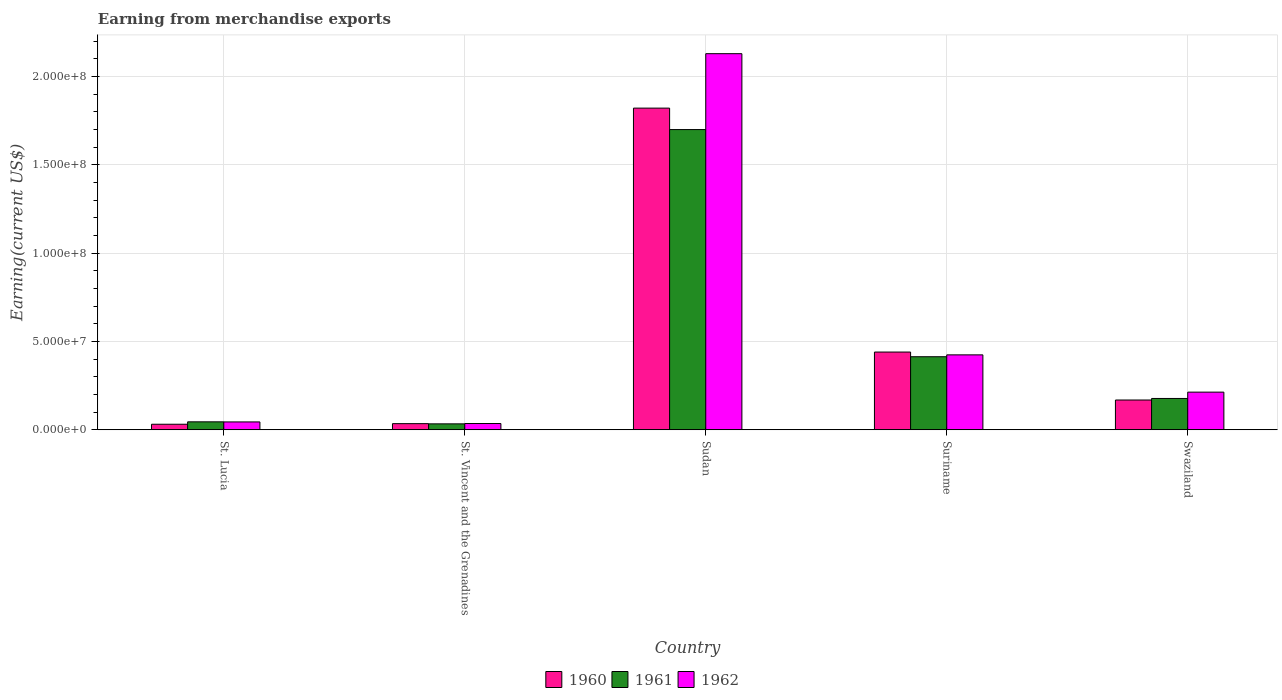What is the label of the 4th group of bars from the left?
Offer a terse response. Suriname. What is the amount earned from merchandise exports in 1960 in St. Vincent and the Grenadines?
Provide a short and direct response. 3.48e+06. Across all countries, what is the maximum amount earned from merchandise exports in 1961?
Your answer should be very brief. 1.70e+08. Across all countries, what is the minimum amount earned from merchandise exports in 1962?
Offer a very short reply. 3.56e+06. In which country was the amount earned from merchandise exports in 1962 maximum?
Your response must be concise. Sudan. In which country was the amount earned from merchandise exports in 1960 minimum?
Keep it short and to the point. St. Lucia. What is the total amount earned from merchandise exports in 1960 in the graph?
Keep it short and to the point. 2.50e+08. What is the difference between the amount earned from merchandise exports in 1962 in St. Lucia and that in St. Vincent and the Grenadines?
Your answer should be very brief. 9.00e+05. What is the difference between the amount earned from merchandise exports in 1962 in St. Lucia and the amount earned from merchandise exports in 1960 in Swaziland?
Ensure brevity in your answer.  -1.24e+07. What is the average amount earned from merchandise exports in 1960 per country?
Your answer should be compact. 4.99e+07. What is the difference between the amount earned from merchandise exports of/in 1961 and amount earned from merchandise exports of/in 1962 in St. Lucia?
Your answer should be compact. 5.54e+04. In how many countries, is the amount earned from merchandise exports in 1961 greater than 40000000 US$?
Make the answer very short. 2. What is the ratio of the amount earned from merchandise exports in 1960 in Sudan to that in Swaziland?
Provide a short and direct response. 10.79. Is the difference between the amount earned from merchandise exports in 1961 in St. Lucia and Sudan greater than the difference between the amount earned from merchandise exports in 1962 in St. Lucia and Sudan?
Your answer should be very brief. Yes. What is the difference between the highest and the second highest amount earned from merchandise exports in 1961?
Ensure brevity in your answer.  1.52e+08. What is the difference between the highest and the lowest amount earned from merchandise exports in 1962?
Give a very brief answer. 2.09e+08. In how many countries, is the amount earned from merchandise exports in 1961 greater than the average amount earned from merchandise exports in 1961 taken over all countries?
Keep it short and to the point. 1. Is the sum of the amount earned from merchandise exports in 1961 in St. Lucia and St. Vincent and the Grenadines greater than the maximum amount earned from merchandise exports in 1960 across all countries?
Provide a short and direct response. No. What does the 2nd bar from the left in St. Vincent and the Grenadines represents?
Provide a succinct answer. 1961. How many bars are there?
Offer a very short reply. 15. Are the values on the major ticks of Y-axis written in scientific E-notation?
Ensure brevity in your answer.  Yes. Does the graph contain any zero values?
Keep it short and to the point. No. Where does the legend appear in the graph?
Give a very brief answer. Bottom center. How many legend labels are there?
Your answer should be compact. 3. How are the legend labels stacked?
Offer a very short reply. Horizontal. What is the title of the graph?
Give a very brief answer. Earning from merchandise exports. Does "2014" appear as one of the legend labels in the graph?
Keep it short and to the point. No. What is the label or title of the Y-axis?
Your answer should be compact. Earning(current US$). What is the Earning(current US$) in 1960 in St. Lucia?
Offer a very short reply. 3.15e+06. What is the Earning(current US$) in 1961 in St. Lucia?
Your answer should be very brief. 4.51e+06. What is the Earning(current US$) in 1962 in St. Lucia?
Make the answer very short. 4.46e+06. What is the Earning(current US$) of 1960 in St. Vincent and the Grenadines?
Keep it short and to the point. 3.48e+06. What is the Earning(current US$) in 1961 in St. Vincent and the Grenadines?
Offer a very short reply. 3.37e+06. What is the Earning(current US$) in 1962 in St. Vincent and the Grenadines?
Provide a short and direct response. 3.56e+06. What is the Earning(current US$) of 1960 in Sudan?
Offer a very short reply. 1.82e+08. What is the Earning(current US$) of 1961 in Sudan?
Provide a succinct answer. 1.70e+08. What is the Earning(current US$) in 1962 in Sudan?
Offer a terse response. 2.13e+08. What is the Earning(current US$) in 1960 in Suriname?
Keep it short and to the point. 4.40e+07. What is the Earning(current US$) of 1961 in Suriname?
Keep it short and to the point. 4.14e+07. What is the Earning(current US$) in 1962 in Suriname?
Give a very brief answer. 4.24e+07. What is the Earning(current US$) in 1960 in Swaziland?
Give a very brief answer. 1.69e+07. What is the Earning(current US$) in 1961 in Swaziland?
Give a very brief answer. 1.77e+07. What is the Earning(current US$) in 1962 in Swaziland?
Offer a terse response. 2.13e+07. Across all countries, what is the maximum Earning(current US$) in 1960?
Your answer should be very brief. 1.82e+08. Across all countries, what is the maximum Earning(current US$) in 1961?
Provide a succinct answer. 1.70e+08. Across all countries, what is the maximum Earning(current US$) in 1962?
Give a very brief answer. 2.13e+08. Across all countries, what is the minimum Earning(current US$) in 1960?
Keep it short and to the point. 3.15e+06. Across all countries, what is the minimum Earning(current US$) of 1961?
Make the answer very short. 3.37e+06. Across all countries, what is the minimum Earning(current US$) of 1962?
Your answer should be compact. 3.56e+06. What is the total Earning(current US$) in 1960 in the graph?
Offer a very short reply. 2.50e+08. What is the total Earning(current US$) in 1961 in the graph?
Give a very brief answer. 2.37e+08. What is the total Earning(current US$) in 1962 in the graph?
Provide a short and direct response. 2.85e+08. What is the difference between the Earning(current US$) of 1960 in St. Lucia and that in St. Vincent and the Grenadines?
Offer a very short reply. -3.35e+05. What is the difference between the Earning(current US$) of 1961 in St. Lucia and that in St. Vincent and the Grenadines?
Give a very brief answer. 1.14e+06. What is the difference between the Earning(current US$) in 1962 in St. Lucia and that in St. Vincent and the Grenadines?
Make the answer very short. 9.00e+05. What is the difference between the Earning(current US$) of 1960 in St. Lucia and that in Sudan?
Make the answer very short. -1.79e+08. What is the difference between the Earning(current US$) in 1961 in St. Lucia and that in Sudan?
Your answer should be compact. -1.65e+08. What is the difference between the Earning(current US$) in 1962 in St. Lucia and that in Sudan?
Your answer should be very brief. -2.08e+08. What is the difference between the Earning(current US$) of 1960 in St. Lucia and that in Suriname?
Ensure brevity in your answer.  -4.09e+07. What is the difference between the Earning(current US$) of 1961 in St. Lucia and that in Suriname?
Your answer should be compact. -3.68e+07. What is the difference between the Earning(current US$) of 1962 in St. Lucia and that in Suriname?
Offer a very short reply. -3.80e+07. What is the difference between the Earning(current US$) of 1960 in St. Lucia and that in Swaziland?
Provide a short and direct response. -1.37e+07. What is the difference between the Earning(current US$) of 1961 in St. Lucia and that in Swaziland?
Your response must be concise. -1.32e+07. What is the difference between the Earning(current US$) in 1962 in St. Lucia and that in Swaziland?
Give a very brief answer. -1.69e+07. What is the difference between the Earning(current US$) of 1960 in St. Vincent and the Grenadines and that in Sudan?
Your answer should be very brief. -1.79e+08. What is the difference between the Earning(current US$) of 1961 in St. Vincent and the Grenadines and that in Sudan?
Your answer should be very brief. -1.67e+08. What is the difference between the Earning(current US$) in 1962 in St. Vincent and the Grenadines and that in Sudan?
Your answer should be very brief. -2.09e+08. What is the difference between the Earning(current US$) in 1960 in St. Vincent and the Grenadines and that in Suriname?
Your answer should be compact. -4.05e+07. What is the difference between the Earning(current US$) of 1961 in St. Vincent and the Grenadines and that in Suriname?
Your response must be concise. -3.80e+07. What is the difference between the Earning(current US$) of 1962 in St. Vincent and the Grenadines and that in Suriname?
Ensure brevity in your answer.  -3.89e+07. What is the difference between the Earning(current US$) of 1960 in St. Vincent and the Grenadines and that in Swaziland?
Make the answer very short. -1.34e+07. What is the difference between the Earning(current US$) of 1961 in St. Vincent and the Grenadines and that in Swaziland?
Make the answer very short. -1.44e+07. What is the difference between the Earning(current US$) in 1962 in St. Vincent and the Grenadines and that in Swaziland?
Your answer should be very brief. -1.78e+07. What is the difference between the Earning(current US$) of 1960 in Sudan and that in Suriname?
Provide a succinct answer. 1.38e+08. What is the difference between the Earning(current US$) of 1961 in Sudan and that in Suriname?
Your answer should be compact. 1.29e+08. What is the difference between the Earning(current US$) in 1962 in Sudan and that in Suriname?
Keep it short and to the point. 1.70e+08. What is the difference between the Earning(current US$) in 1960 in Sudan and that in Swaziland?
Make the answer very short. 1.65e+08. What is the difference between the Earning(current US$) of 1961 in Sudan and that in Swaziland?
Offer a terse response. 1.52e+08. What is the difference between the Earning(current US$) of 1962 in Sudan and that in Swaziland?
Provide a succinct answer. 1.92e+08. What is the difference between the Earning(current US$) of 1960 in Suriname and that in Swaziland?
Offer a terse response. 2.71e+07. What is the difference between the Earning(current US$) of 1961 in Suriname and that in Swaziland?
Your response must be concise. 2.36e+07. What is the difference between the Earning(current US$) of 1962 in Suriname and that in Swaziland?
Keep it short and to the point. 2.11e+07. What is the difference between the Earning(current US$) of 1960 in St. Lucia and the Earning(current US$) of 1961 in St. Vincent and the Grenadines?
Provide a short and direct response. -2.23e+05. What is the difference between the Earning(current US$) of 1960 in St. Lucia and the Earning(current US$) of 1962 in St. Vincent and the Grenadines?
Offer a very short reply. -4.11e+05. What is the difference between the Earning(current US$) of 1961 in St. Lucia and the Earning(current US$) of 1962 in St. Vincent and the Grenadines?
Provide a succinct answer. 9.56e+05. What is the difference between the Earning(current US$) of 1960 in St. Lucia and the Earning(current US$) of 1961 in Sudan?
Your answer should be compact. -1.67e+08. What is the difference between the Earning(current US$) of 1960 in St. Lucia and the Earning(current US$) of 1962 in Sudan?
Keep it short and to the point. -2.10e+08. What is the difference between the Earning(current US$) of 1961 in St. Lucia and the Earning(current US$) of 1962 in Sudan?
Provide a short and direct response. -2.08e+08. What is the difference between the Earning(current US$) in 1960 in St. Lucia and the Earning(current US$) in 1961 in Suriname?
Provide a succinct answer. -3.82e+07. What is the difference between the Earning(current US$) of 1960 in St. Lucia and the Earning(current US$) of 1962 in Suriname?
Provide a succinct answer. -3.93e+07. What is the difference between the Earning(current US$) of 1961 in St. Lucia and the Earning(current US$) of 1962 in Suriname?
Offer a terse response. -3.79e+07. What is the difference between the Earning(current US$) of 1960 in St. Lucia and the Earning(current US$) of 1961 in Swaziland?
Your response must be concise. -1.46e+07. What is the difference between the Earning(current US$) of 1960 in St. Lucia and the Earning(current US$) of 1962 in Swaziland?
Your answer should be very brief. -1.82e+07. What is the difference between the Earning(current US$) of 1961 in St. Lucia and the Earning(current US$) of 1962 in Swaziland?
Give a very brief answer. -1.68e+07. What is the difference between the Earning(current US$) in 1960 in St. Vincent and the Grenadines and the Earning(current US$) in 1961 in Sudan?
Your response must be concise. -1.66e+08. What is the difference between the Earning(current US$) of 1960 in St. Vincent and the Grenadines and the Earning(current US$) of 1962 in Sudan?
Offer a terse response. -2.09e+08. What is the difference between the Earning(current US$) in 1961 in St. Vincent and the Grenadines and the Earning(current US$) in 1962 in Sudan?
Your answer should be compact. -2.10e+08. What is the difference between the Earning(current US$) of 1960 in St. Vincent and the Grenadines and the Earning(current US$) of 1961 in Suriname?
Offer a very short reply. -3.79e+07. What is the difference between the Earning(current US$) in 1960 in St. Vincent and the Grenadines and the Earning(current US$) in 1962 in Suriname?
Make the answer very short. -3.89e+07. What is the difference between the Earning(current US$) of 1961 in St. Vincent and the Grenadines and the Earning(current US$) of 1962 in Suriname?
Keep it short and to the point. -3.91e+07. What is the difference between the Earning(current US$) in 1960 in St. Vincent and the Grenadines and the Earning(current US$) in 1961 in Swaziland?
Provide a short and direct response. -1.43e+07. What is the difference between the Earning(current US$) in 1960 in St. Vincent and the Grenadines and the Earning(current US$) in 1962 in Swaziland?
Ensure brevity in your answer.  -1.78e+07. What is the difference between the Earning(current US$) of 1961 in St. Vincent and the Grenadines and the Earning(current US$) of 1962 in Swaziland?
Offer a terse response. -1.80e+07. What is the difference between the Earning(current US$) of 1960 in Sudan and the Earning(current US$) of 1961 in Suriname?
Your answer should be very brief. 1.41e+08. What is the difference between the Earning(current US$) in 1960 in Sudan and the Earning(current US$) in 1962 in Suriname?
Offer a very short reply. 1.40e+08. What is the difference between the Earning(current US$) of 1961 in Sudan and the Earning(current US$) of 1962 in Suriname?
Ensure brevity in your answer.  1.28e+08. What is the difference between the Earning(current US$) in 1960 in Sudan and the Earning(current US$) in 1961 in Swaziland?
Your response must be concise. 1.64e+08. What is the difference between the Earning(current US$) of 1960 in Sudan and the Earning(current US$) of 1962 in Swaziland?
Your response must be concise. 1.61e+08. What is the difference between the Earning(current US$) in 1961 in Sudan and the Earning(current US$) in 1962 in Swaziland?
Provide a succinct answer. 1.49e+08. What is the difference between the Earning(current US$) of 1960 in Suriname and the Earning(current US$) of 1961 in Swaziland?
Keep it short and to the point. 2.63e+07. What is the difference between the Earning(current US$) of 1960 in Suriname and the Earning(current US$) of 1962 in Swaziland?
Offer a terse response. 2.27e+07. What is the difference between the Earning(current US$) in 1961 in Suriname and the Earning(current US$) in 1962 in Swaziland?
Offer a terse response. 2.00e+07. What is the average Earning(current US$) in 1960 per country?
Give a very brief answer. 4.99e+07. What is the average Earning(current US$) of 1961 per country?
Keep it short and to the point. 4.74e+07. What is the average Earning(current US$) of 1962 per country?
Offer a very short reply. 5.69e+07. What is the difference between the Earning(current US$) of 1960 and Earning(current US$) of 1961 in St. Lucia?
Offer a terse response. -1.37e+06. What is the difference between the Earning(current US$) in 1960 and Earning(current US$) in 1962 in St. Lucia?
Offer a very short reply. -1.31e+06. What is the difference between the Earning(current US$) in 1961 and Earning(current US$) in 1962 in St. Lucia?
Provide a short and direct response. 5.54e+04. What is the difference between the Earning(current US$) in 1960 and Earning(current US$) in 1961 in St. Vincent and the Grenadines?
Provide a succinct answer. 1.12e+05. What is the difference between the Earning(current US$) of 1960 and Earning(current US$) of 1962 in St. Vincent and the Grenadines?
Your answer should be very brief. -7.52e+04. What is the difference between the Earning(current US$) of 1961 and Earning(current US$) of 1962 in St. Vincent and the Grenadines?
Your answer should be very brief. -1.87e+05. What is the difference between the Earning(current US$) in 1960 and Earning(current US$) in 1961 in Sudan?
Offer a very short reply. 1.21e+07. What is the difference between the Earning(current US$) in 1960 and Earning(current US$) in 1962 in Sudan?
Your answer should be compact. -3.08e+07. What is the difference between the Earning(current US$) of 1961 and Earning(current US$) of 1962 in Sudan?
Offer a terse response. -4.30e+07. What is the difference between the Earning(current US$) in 1960 and Earning(current US$) in 1961 in Suriname?
Offer a very short reply. 2.65e+06. What is the difference between the Earning(current US$) in 1960 and Earning(current US$) in 1962 in Suriname?
Make the answer very short. 1.59e+06. What is the difference between the Earning(current US$) in 1961 and Earning(current US$) in 1962 in Suriname?
Ensure brevity in your answer.  -1.06e+06. What is the difference between the Earning(current US$) in 1960 and Earning(current US$) in 1961 in Swaziland?
Keep it short and to the point. -8.68e+05. What is the difference between the Earning(current US$) of 1960 and Earning(current US$) of 1962 in Swaziland?
Ensure brevity in your answer.  -4.45e+06. What is the difference between the Earning(current US$) in 1961 and Earning(current US$) in 1962 in Swaziland?
Provide a short and direct response. -3.58e+06. What is the ratio of the Earning(current US$) of 1960 in St. Lucia to that in St. Vincent and the Grenadines?
Offer a terse response. 0.9. What is the ratio of the Earning(current US$) in 1961 in St. Lucia to that in St. Vincent and the Grenadines?
Keep it short and to the point. 1.34. What is the ratio of the Earning(current US$) of 1962 in St. Lucia to that in St. Vincent and the Grenadines?
Provide a succinct answer. 1.25. What is the ratio of the Earning(current US$) in 1960 in St. Lucia to that in Sudan?
Give a very brief answer. 0.02. What is the ratio of the Earning(current US$) of 1961 in St. Lucia to that in Sudan?
Provide a succinct answer. 0.03. What is the ratio of the Earning(current US$) in 1962 in St. Lucia to that in Sudan?
Make the answer very short. 0.02. What is the ratio of the Earning(current US$) in 1960 in St. Lucia to that in Suriname?
Give a very brief answer. 0.07. What is the ratio of the Earning(current US$) in 1961 in St. Lucia to that in Suriname?
Give a very brief answer. 0.11. What is the ratio of the Earning(current US$) in 1962 in St. Lucia to that in Suriname?
Give a very brief answer. 0.11. What is the ratio of the Earning(current US$) of 1960 in St. Lucia to that in Swaziland?
Provide a succinct answer. 0.19. What is the ratio of the Earning(current US$) in 1961 in St. Lucia to that in Swaziland?
Give a very brief answer. 0.25. What is the ratio of the Earning(current US$) in 1962 in St. Lucia to that in Swaziland?
Your response must be concise. 0.21. What is the ratio of the Earning(current US$) of 1960 in St. Vincent and the Grenadines to that in Sudan?
Your response must be concise. 0.02. What is the ratio of the Earning(current US$) in 1961 in St. Vincent and the Grenadines to that in Sudan?
Ensure brevity in your answer.  0.02. What is the ratio of the Earning(current US$) in 1962 in St. Vincent and the Grenadines to that in Sudan?
Give a very brief answer. 0.02. What is the ratio of the Earning(current US$) of 1960 in St. Vincent and the Grenadines to that in Suriname?
Ensure brevity in your answer.  0.08. What is the ratio of the Earning(current US$) of 1961 in St. Vincent and the Grenadines to that in Suriname?
Keep it short and to the point. 0.08. What is the ratio of the Earning(current US$) of 1962 in St. Vincent and the Grenadines to that in Suriname?
Make the answer very short. 0.08. What is the ratio of the Earning(current US$) of 1960 in St. Vincent and the Grenadines to that in Swaziland?
Give a very brief answer. 0.21. What is the ratio of the Earning(current US$) in 1961 in St. Vincent and the Grenadines to that in Swaziland?
Offer a very short reply. 0.19. What is the ratio of the Earning(current US$) in 1962 in St. Vincent and the Grenadines to that in Swaziland?
Your answer should be very brief. 0.17. What is the ratio of the Earning(current US$) of 1960 in Sudan to that in Suriname?
Offer a terse response. 4.14. What is the ratio of the Earning(current US$) in 1961 in Sudan to that in Suriname?
Your answer should be compact. 4.11. What is the ratio of the Earning(current US$) in 1962 in Sudan to that in Suriname?
Keep it short and to the point. 5.02. What is the ratio of the Earning(current US$) in 1960 in Sudan to that in Swaziland?
Keep it short and to the point. 10.79. What is the ratio of the Earning(current US$) of 1961 in Sudan to that in Swaziland?
Your answer should be very brief. 9.58. What is the ratio of the Earning(current US$) of 1962 in Sudan to that in Swaziland?
Provide a succinct answer. 9.98. What is the ratio of the Earning(current US$) in 1960 in Suriname to that in Swaziland?
Provide a short and direct response. 2.61. What is the ratio of the Earning(current US$) of 1961 in Suriname to that in Swaziland?
Your response must be concise. 2.33. What is the ratio of the Earning(current US$) in 1962 in Suriname to that in Swaziland?
Offer a terse response. 1.99. What is the difference between the highest and the second highest Earning(current US$) of 1960?
Offer a terse response. 1.38e+08. What is the difference between the highest and the second highest Earning(current US$) of 1961?
Make the answer very short. 1.29e+08. What is the difference between the highest and the second highest Earning(current US$) in 1962?
Offer a very short reply. 1.70e+08. What is the difference between the highest and the lowest Earning(current US$) in 1960?
Make the answer very short. 1.79e+08. What is the difference between the highest and the lowest Earning(current US$) of 1961?
Provide a short and direct response. 1.67e+08. What is the difference between the highest and the lowest Earning(current US$) of 1962?
Offer a terse response. 2.09e+08. 